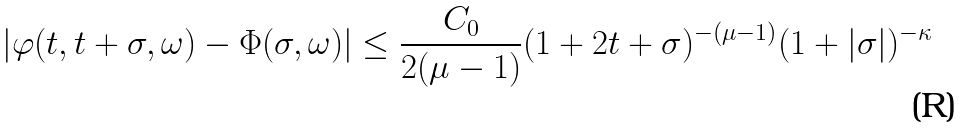Convert formula to latex. <formula><loc_0><loc_0><loc_500><loc_500>| \varphi ( t , t + \sigma , \omega ) - \Phi ( \sigma , \omega ) | \leq \frac { C _ { 0 } } { 2 ( \mu - 1 ) } ( 1 + 2 t + \sigma ) ^ { - ( \mu - 1 ) } ( 1 + | \sigma | ) ^ { - \kappa }</formula> 